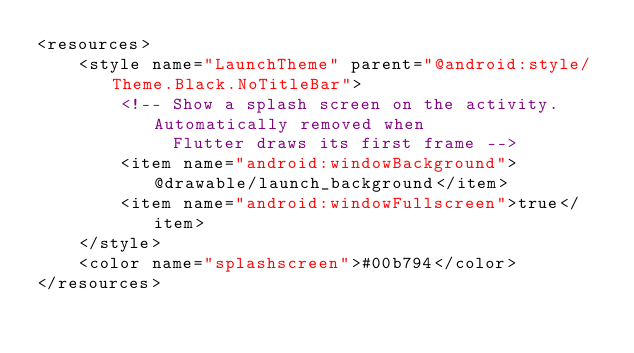<code> <loc_0><loc_0><loc_500><loc_500><_XML_><resources>
    <style name="LaunchTheme" parent="@android:style/Theme.Black.NoTitleBar">
        <!-- Show a splash screen on the activity. Automatically removed when
             Flutter draws its first frame -->
        <item name="android:windowBackground">@drawable/launch_background</item>
        <item name="android:windowFullscreen">true</item>
    </style>
    <color name="splashscreen">#00b794</color>
</resources>
</code> 